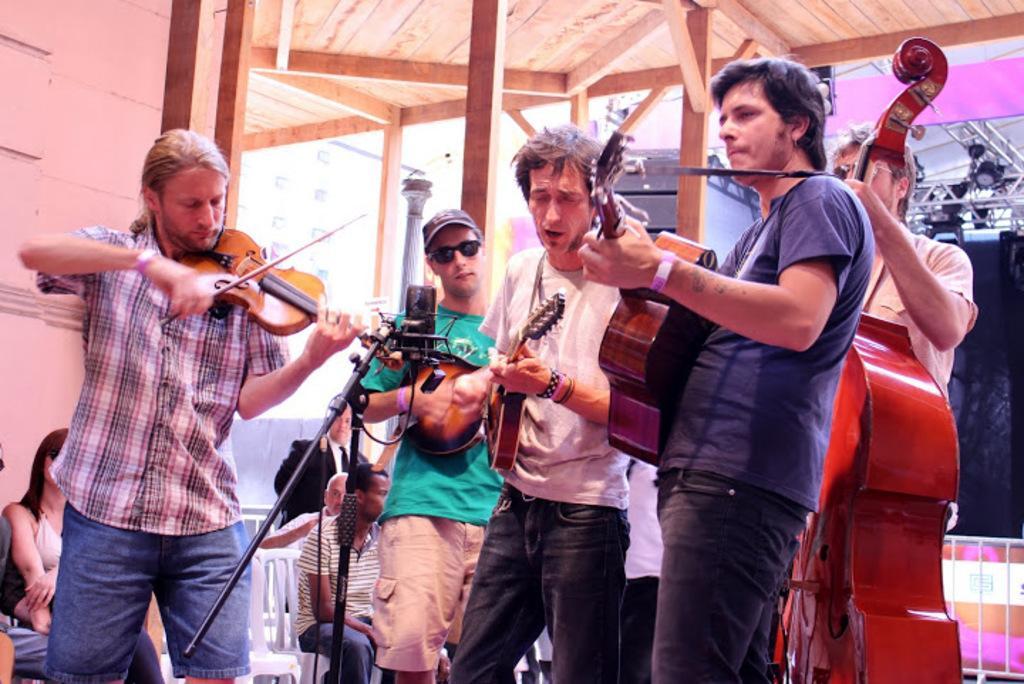In one or two sentences, can you explain what this image depicts? This persons are standing and playing a musical instruments in-front of mic. Far this persons are sitting on chair. This is a roof top with wood. 